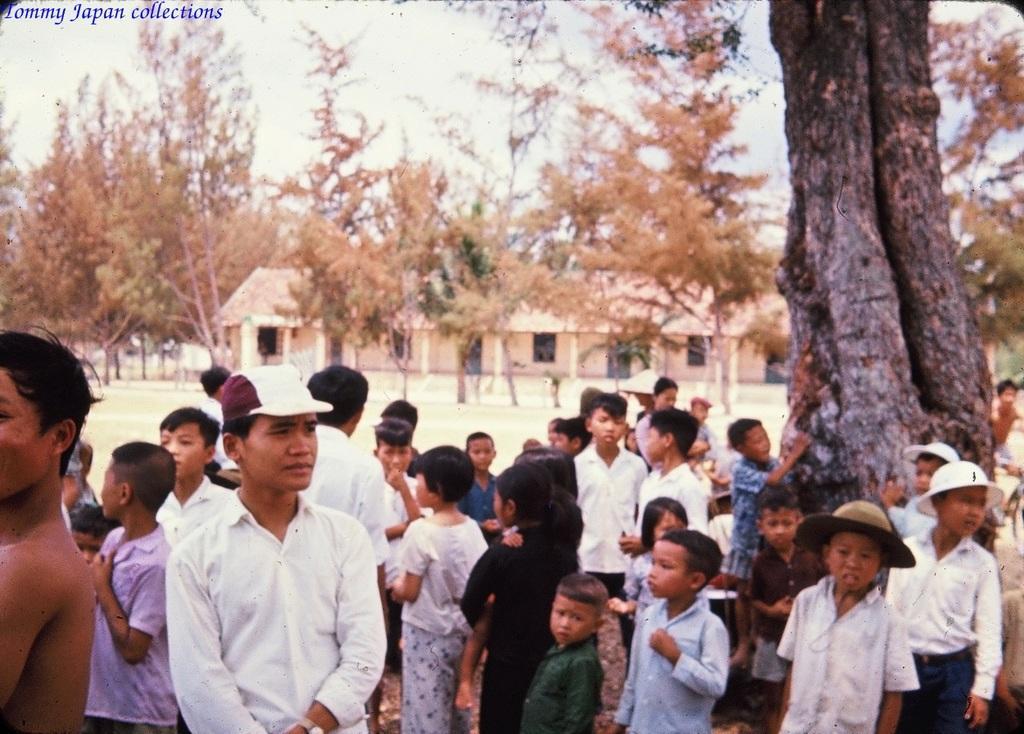In one or two sentences, can you explain what this image depicts? In this image I can see a tree on the right side and near it I can see number of children are standing. I can also see most of them are wearing white colour dress and caps. In the background I can see few more trees, a building and the sky. On the top left side of the image I can see a watermark. 